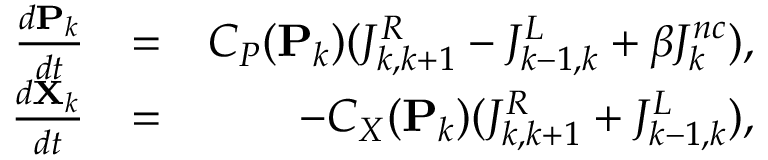<formula> <loc_0><loc_0><loc_500><loc_500>\begin{array} { r l r } { \frac { d P _ { k } } { d t } } & { = } & { C _ { P } ( P _ { k } ) ( J _ { k , k + 1 } ^ { R } - J _ { k - 1 , k } ^ { L } + \beta J _ { k } ^ { n c } ) , } \\ { \frac { d X _ { k } } { d t } } & { = } & { - C _ { X } ( P _ { k } ) ( J _ { k , k + 1 } ^ { R } + J _ { k - 1 , k } ^ { L } ) , } \end{array}</formula> 